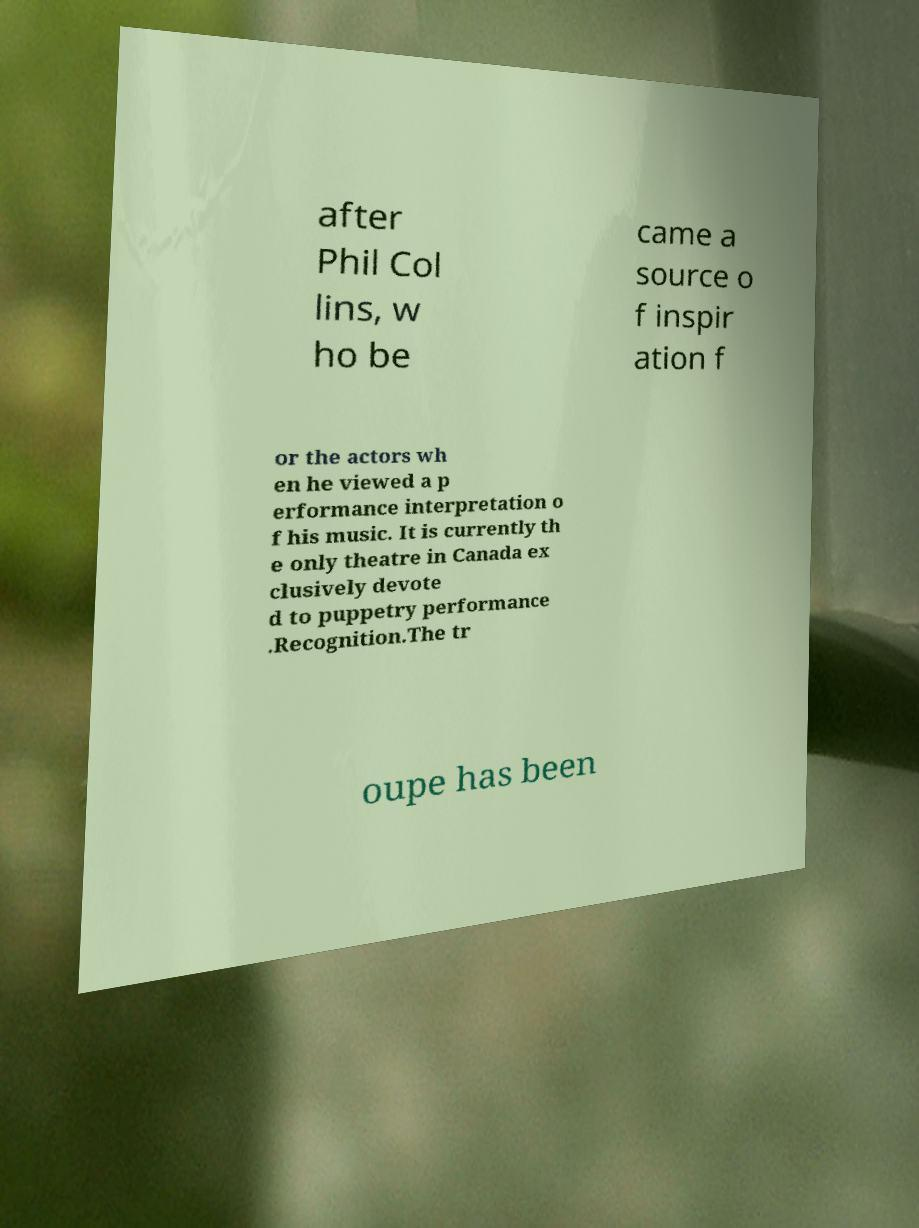There's text embedded in this image that I need extracted. Can you transcribe it verbatim? after Phil Col lins, w ho be came a source o f inspir ation f or the actors wh en he viewed a p erformance interpretation o f his music. It is currently th e only theatre in Canada ex clusively devote d to puppetry performance .Recognition.The tr oupe has been 